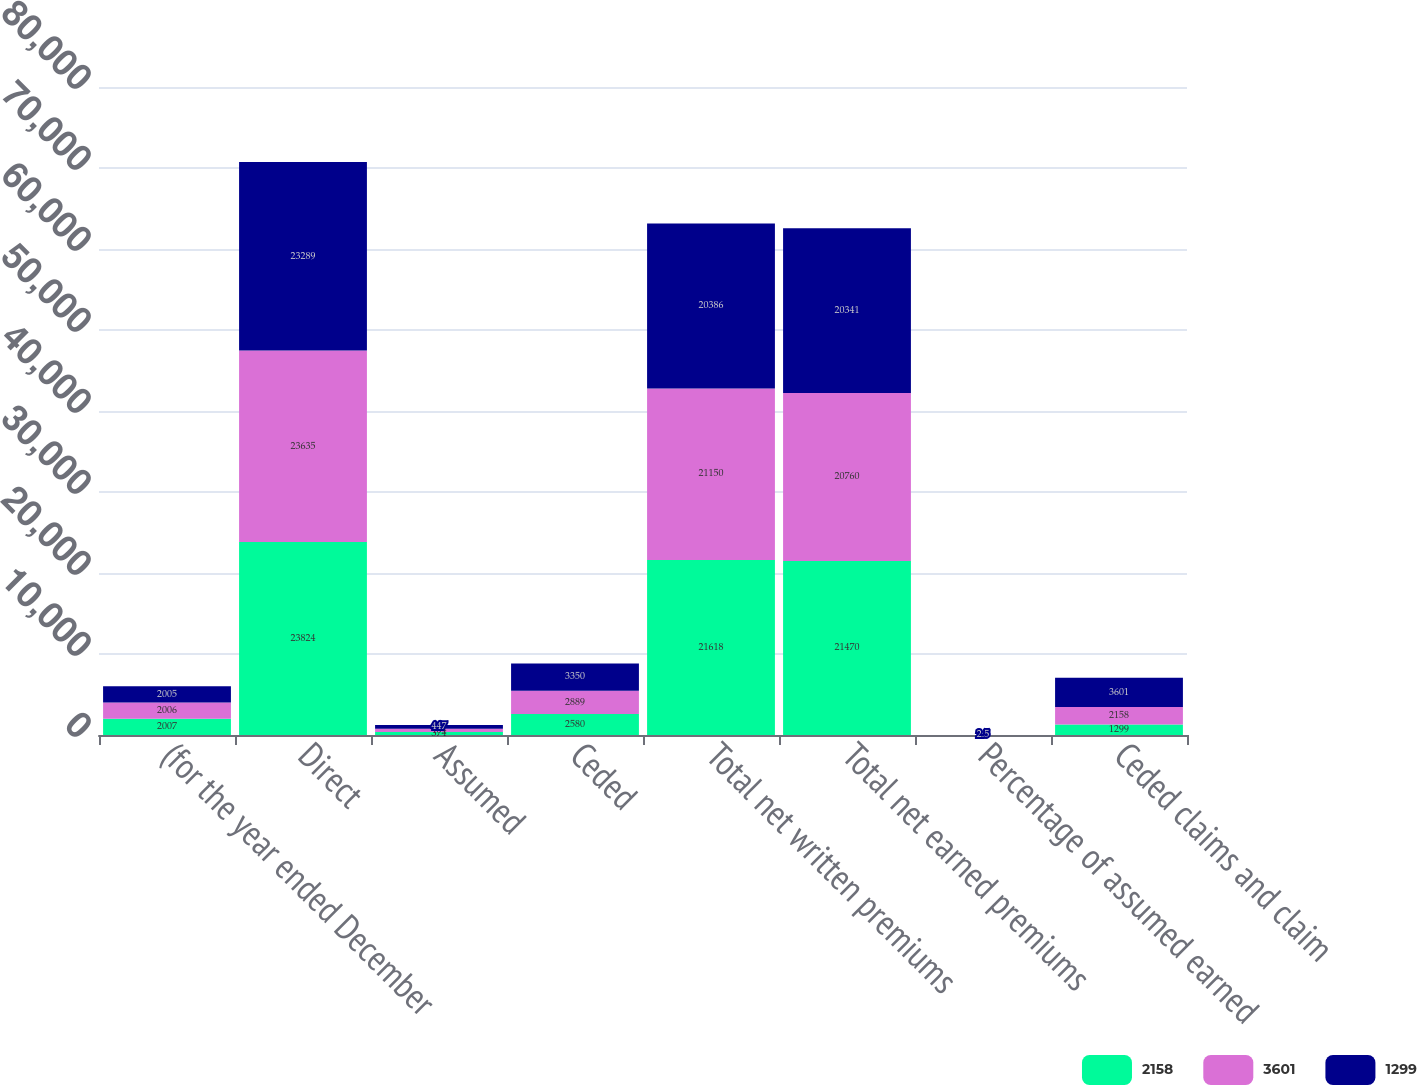Convert chart. <chart><loc_0><loc_0><loc_500><loc_500><stacked_bar_chart><ecel><fcel>(for the year ended December<fcel>Direct<fcel>Assumed<fcel>Ceded<fcel>Total net written premiums<fcel>Total net earned premiums<fcel>Percentage of assumed earned<fcel>Ceded claims and claim<nl><fcel>2158<fcel>2007<fcel>23824<fcel>374<fcel>2580<fcel>21618<fcel>21470<fcel>0.8<fcel>1299<nl><fcel>3601<fcel>2006<fcel>23635<fcel>404<fcel>2889<fcel>21150<fcel>20760<fcel>2.3<fcel>2158<nl><fcel>1299<fcel>2005<fcel>23289<fcel>447<fcel>3350<fcel>20386<fcel>20341<fcel>2.5<fcel>3601<nl></chart> 